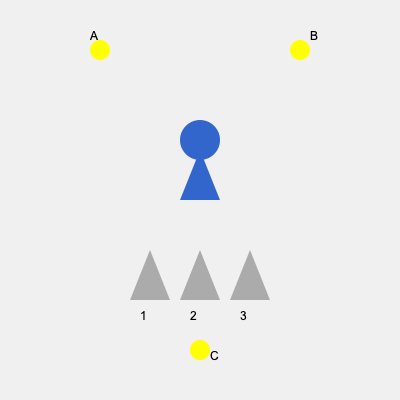In a game development scenario, you're working on a character's shadow system for different light source positions. Given the character's shape and three light sources (A, B, and C), which shadow (1, 2, or 3) corresponds to light source C? To determine the correct shadow for light source C, we need to analyze the position of the light source relative to the character and how it would cast a shadow:

1. Light source A is positioned to the top-left of the character. This would cast a shadow towards the bottom-right (shadow 3).

2. Light source B is positioned to the top-right of the character. This would cast a shadow towards the bottom-left (shadow 1).

3. Light source C is positioned directly below the character. When a light source is directly below an object, it casts a shadow directly above the object.

4. Looking at the shadows, we can see that shadow 2 is directly below the character, which means it's being cast by a light source directly below it.

5. Therefore, shadow 2 corresponds to light source C.

This spatial reasoning is crucial in game development for creating realistic lighting and shadow effects, especially when designing levels or character interactions with the environment.
Answer: 2 